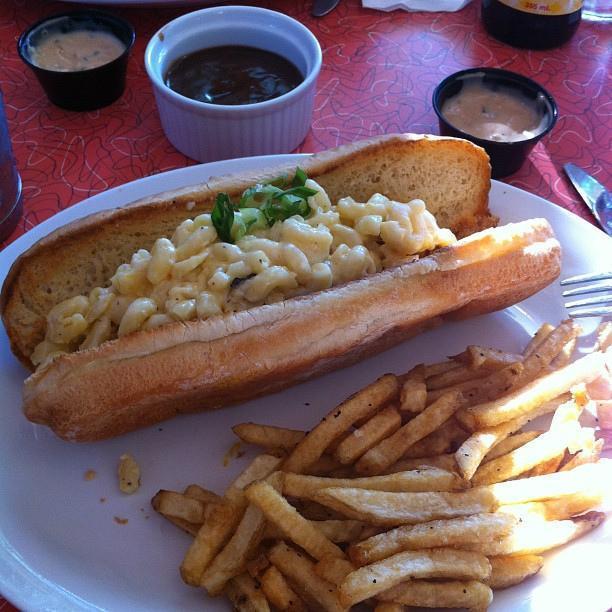What would usually be where the pasta is?
Choose the correct response, then elucidate: 'Answer: answer
Rationale: rationale.'
Options: Eggs, hamburger, meatloaf, hot dog. Answer: hot dog.
Rationale: This is a hot dog bun and normally there would be some kind of long meat in it 